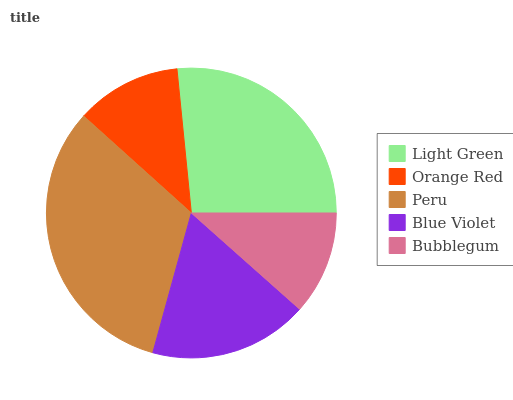Is Bubblegum the minimum?
Answer yes or no. Yes. Is Peru the maximum?
Answer yes or no. Yes. Is Orange Red the minimum?
Answer yes or no. No. Is Orange Red the maximum?
Answer yes or no. No. Is Light Green greater than Orange Red?
Answer yes or no. Yes. Is Orange Red less than Light Green?
Answer yes or no. Yes. Is Orange Red greater than Light Green?
Answer yes or no. No. Is Light Green less than Orange Red?
Answer yes or no. No. Is Blue Violet the high median?
Answer yes or no. Yes. Is Blue Violet the low median?
Answer yes or no. Yes. Is Orange Red the high median?
Answer yes or no. No. Is Peru the low median?
Answer yes or no. No. 